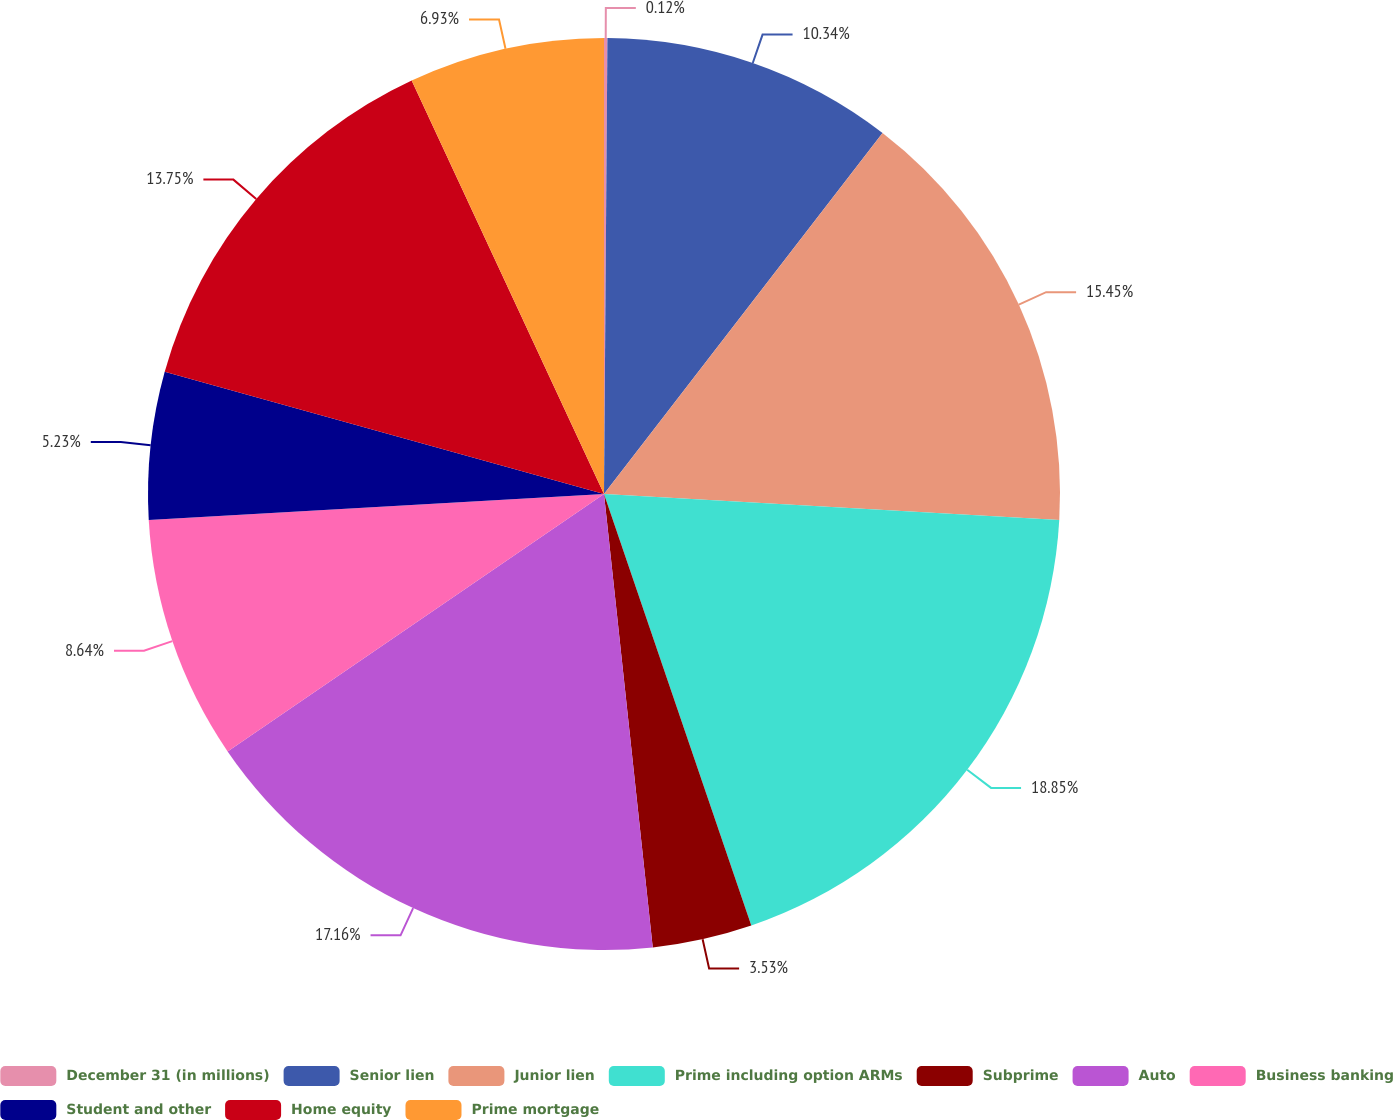Convert chart to OTSL. <chart><loc_0><loc_0><loc_500><loc_500><pie_chart><fcel>December 31 (in millions)<fcel>Senior lien<fcel>Junior lien<fcel>Prime including option ARMs<fcel>Subprime<fcel>Auto<fcel>Business banking<fcel>Student and other<fcel>Home equity<fcel>Prime mortgage<nl><fcel>0.12%<fcel>10.34%<fcel>15.45%<fcel>18.86%<fcel>3.53%<fcel>17.16%<fcel>8.64%<fcel>5.23%<fcel>13.75%<fcel>6.93%<nl></chart> 